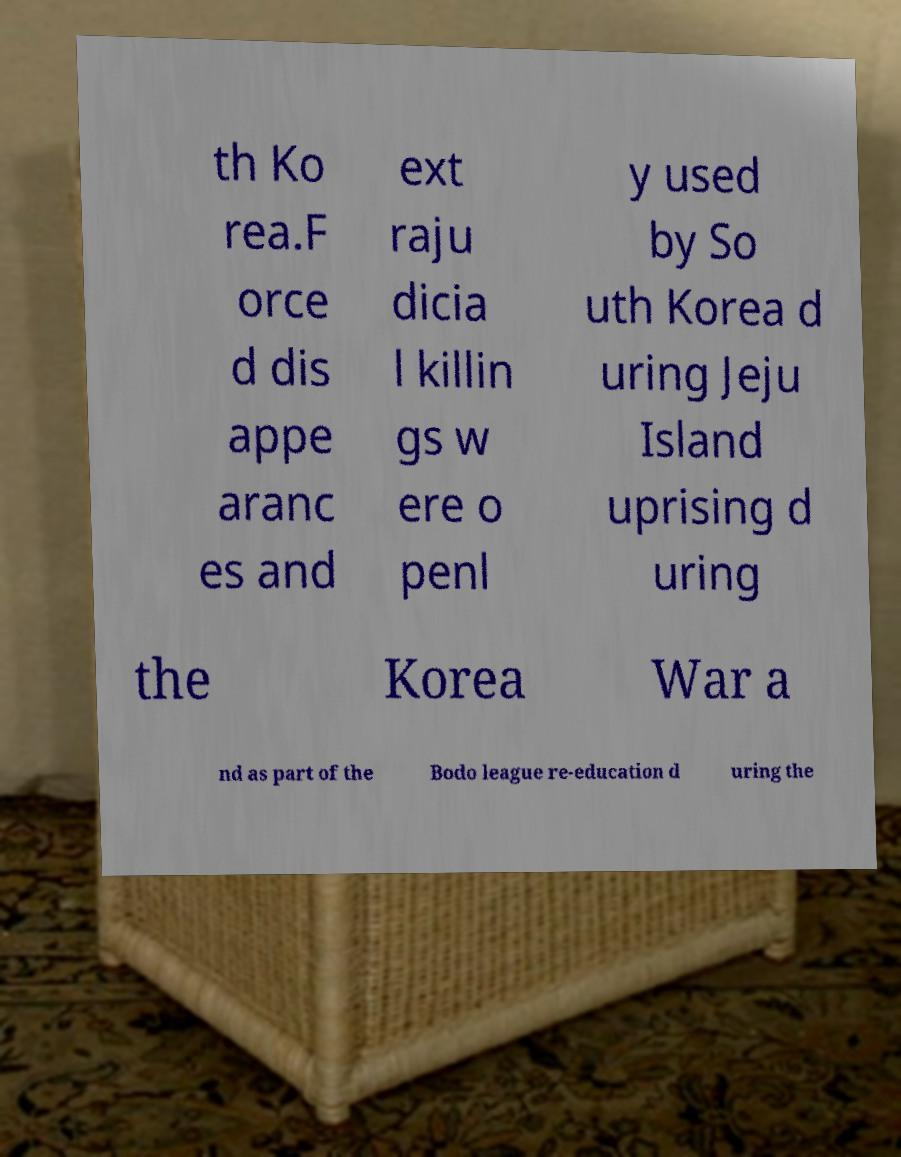There's text embedded in this image that I need extracted. Can you transcribe it verbatim? th Ko rea.F orce d dis appe aranc es and ext raju dicia l killin gs w ere o penl y used by So uth Korea d uring Jeju Island uprising d uring the Korea War a nd as part of the Bodo league re-education d uring the 